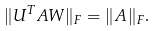<formula> <loc_0><loc_0><loc_500><loc_500>\| U ^ { T } A W \| _ { F } = \| A \| _ { F } .</formula> 